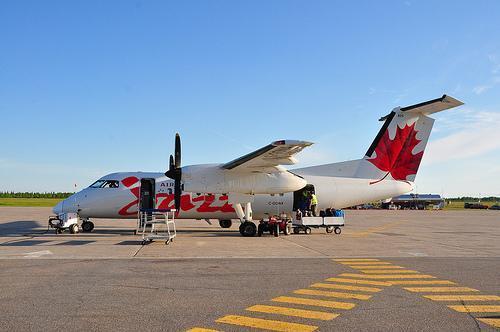How many doors on the plane are open?
Give a very brief answer. 2. 